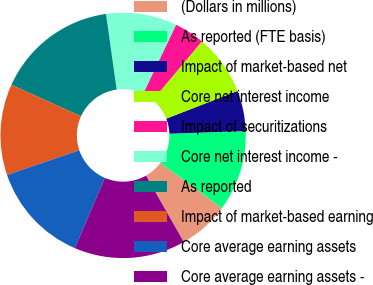<chart> <loc_0><loc_0><loc_500><loc_500><pie_chart><fcel>(Dollars in millions)<fcel>As reported (FTE basis)<fcel>Impact of market-based net<fcel>Core net interest income<fcel>Impact of securitizations<fcel>Core net interest income -<fcel>As reported<fcel>Impact of market-based earning<fcel>Core average earning assets<fcel>Core average earning assets -<nl><fcel>6.67%<fcel>10.67%<fcel>5.33%<fcel>8.0%<fcel>4.0%<fcel>9.33%<fcel>16.0%<fcel>12.0%<fcel>13.33%<fcel>14.67%<nl></chart> 